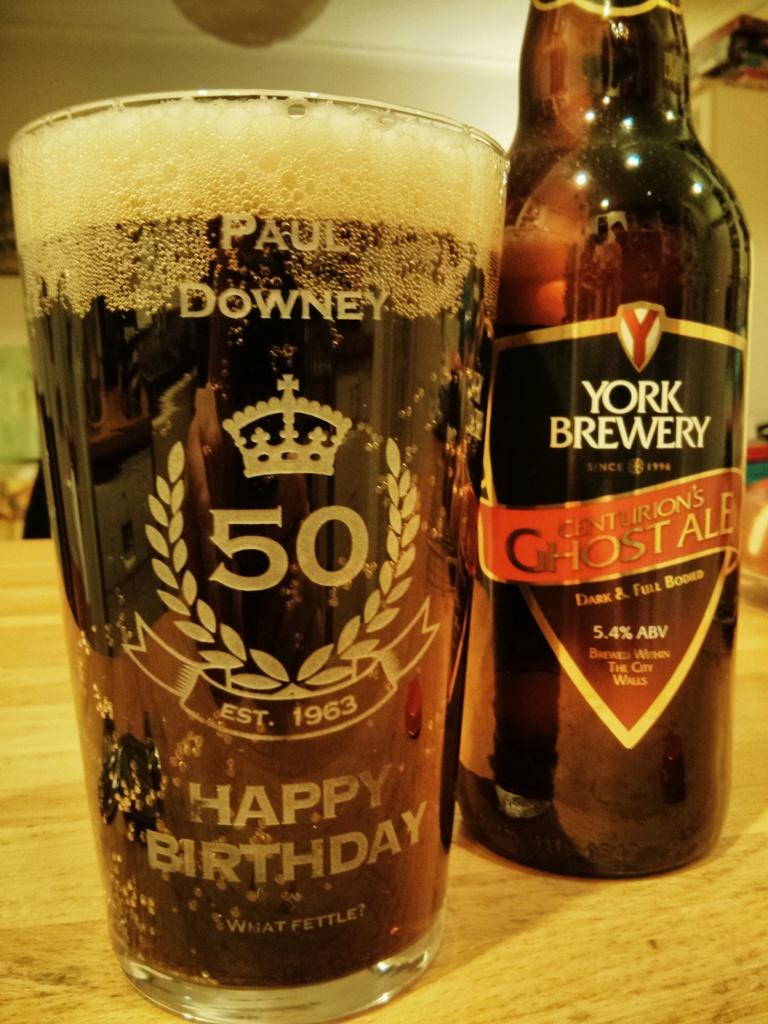Is this person's name paul downey?
Ensure brevity in your answer.  Yes. How old is he?
Your response must be concise. 50. 